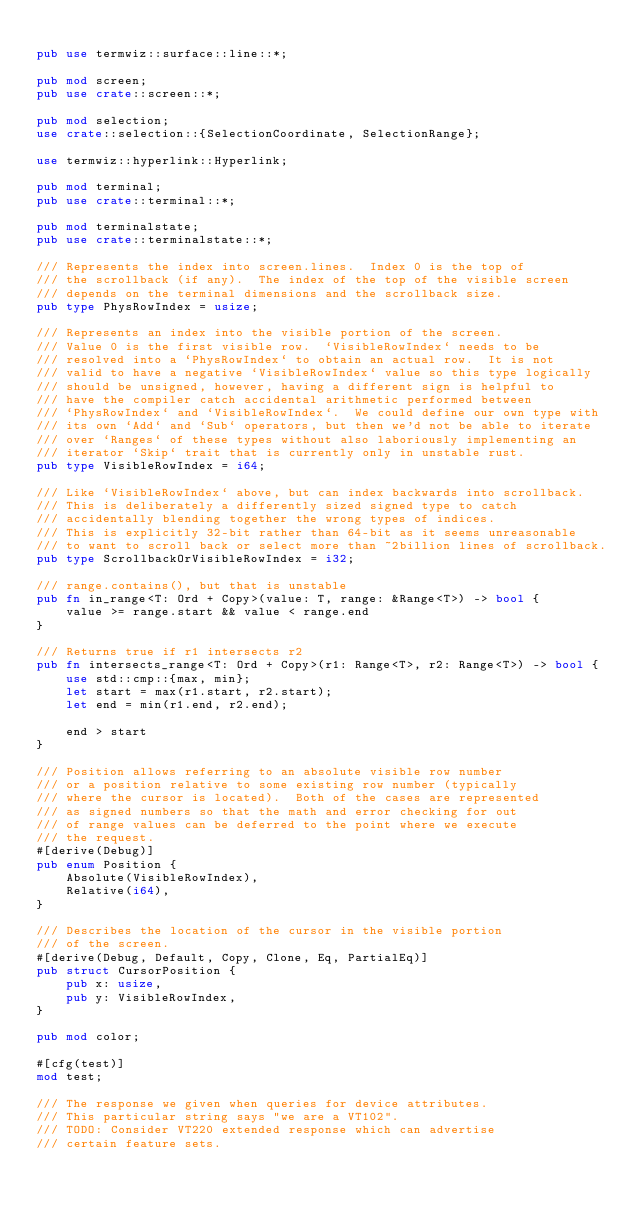Convert code to text. <code><loc_0><loc_0><loc_500><loc_500><_Rust_>
pub use termwiz::surface::line::*;

pub mod screen;
pub use crate::screen::*;

pub mod selection;
use crate::selection::{SelectionCoordinate, SelectionRange};

use termwiz::hyperlink::Hyperlink;

pub mod terminal;
pub use crate::terminal::*;

pub mod terminalstate;
pub use crate::terminalstate::*;

/// Represents the index into screen.lines.  Index 0 is the top of
/// the scrollback (if any).  The index of the top of the visible screen
/// depends on the terminal dimensions and the scrollback size.
pub type PhysRowIndex = usize;

/// Represents an index into the visible portion of the screen.
/// Value 0 is the first visible row.  `VisibleRowIndex` needs to be
/// resolved into a `PhysRowIndex` to obtain an actual row.  It is not
/// valid to have a negative `VisibleRowIndex` value so this type logically
/// should be unsigned, however, having a different sign is helpful to
/// have the compiler catch accidental arithmetic performed between
/// `PhysRowIndex` and `VisibleRowIndex`.  We could define our own type with
/// its own `Add` and `Sub` operators, but then we'd not be able to iterate
/// over `Ranges` of these types without also laboriously implementing an
/// iterator `Skip` trait that is currently only in unstable rust.
pub type VisibleRowIndex = i64;

/// Like `VisibleRowIndex` above, but can index backwards into scrollback.
/// This is deliberately a differently sized signed type to catch
/// accidentally blending together the wrong types of indices.
/// This is explicitly 32-bit rather than 64-bit as it seems unreasonable
/// to want to scroll back or select more than ~2billion lines of scrollback.
pub type ScrollbackOrVisibleRowIndex = i32;

/// range.contains(), but that is unstable
pub fn in_range<T: Ord + Copy>(value: T, range: &Range<T>) -> bool {
    value >= range.start && value < range.end
}

/// Returns true if r1 intersects r2
pub fn intersects_range<T: Ord + Copy>(r1: Range<T>, r2: Range<T>) -> bool {
    use std::cmp::{max, min};
    let start = max(r1.start, r2.start);
    let end = min(r1.end, r2.end);

    end > start
}

/// Position allows referring to an absolute visible row number
/// or a position relative to some existing row number (typically
/// where the cursor is located).  Both of the cases are represented
/// as signed numbers so that the math and error checking for out
/// of range values can be deferred to the point where we execute
/// the request.
#[derive(Debug)]
pub enum Position {
    Absolute(VisibleRowIndex),
    Relative(i64),
}

/// Describes the location of the cursor in the visible portion
/// of the screen.
#[derive(Debug, Default, Copy, Clone, Eq, PartialEq)]
pub struct CursorPosition {
    pub x: usize,
    pub y: VisibleRowIndex,
}

pub mod color;

#[cfg(test)]
mod test;

/// The response we given when queries for device attributes.
/// This particular string says "we are a VT102".
/// TODO: Consider VT220 extended response which can advertise
/// certain feature sets.</code> 